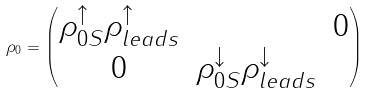<formula> <loc_0><loc_0><loc_500><loc_500>\rho _ { 0 } = \begin{pmatrix} \rho _ { 0 S } ^ { \uparrow } \rho ^ { \uparrow } _ { l e a d s } & & 0 \\ 0 & \rho _ { 0 S } ^ { \downarrow } \rho ^ { \downarrow } _ { l e a d s } \end{pmatrix}</formula> 